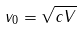Convert formula to latex. <formula><loc_0><loc_0><loc_500><loc_500>v _ { 0 } = \sqrt { c V }</formula> 